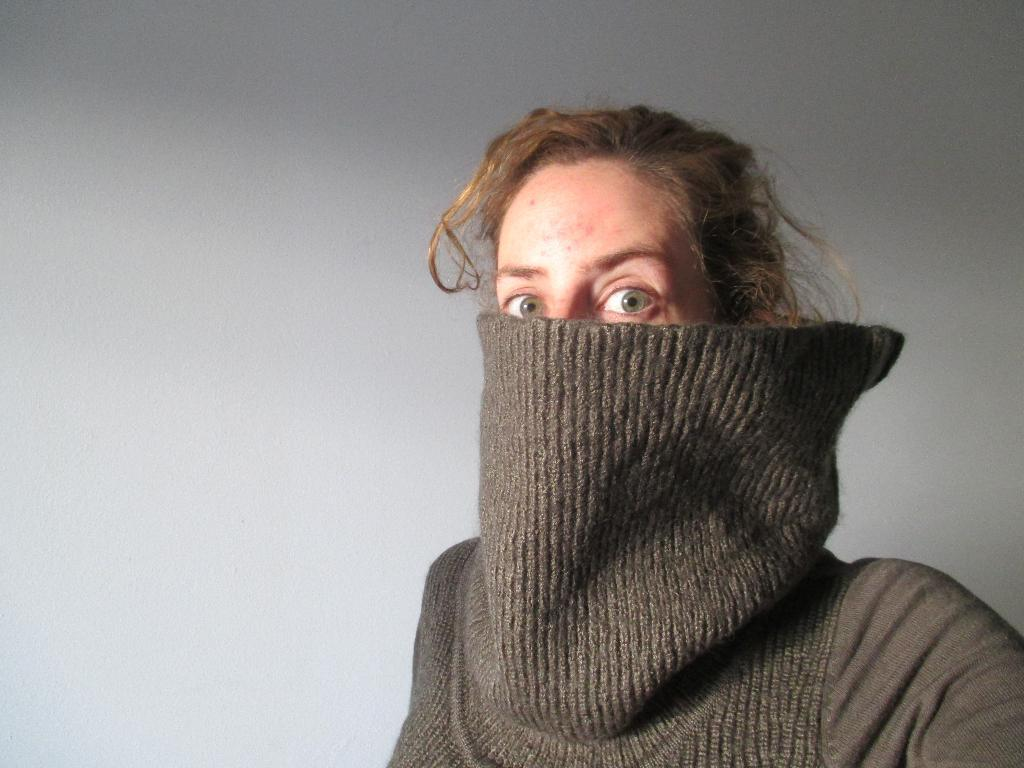What is present in the image? There is a person in the image. Can you describe the person's clothing? The person is wearing a grey jacket. What can be seen in the background of the image? There is a white wall in the background of the image. What type of airplane is the person flying in the image? There is no airplane present in the image; it only features a person wearing a grey jacket in front of a white wall. What is the person's digestive system like in the image? The image does not show the person's digestive system; it only shows the person wearing a grey jacket in front of a white wall. 